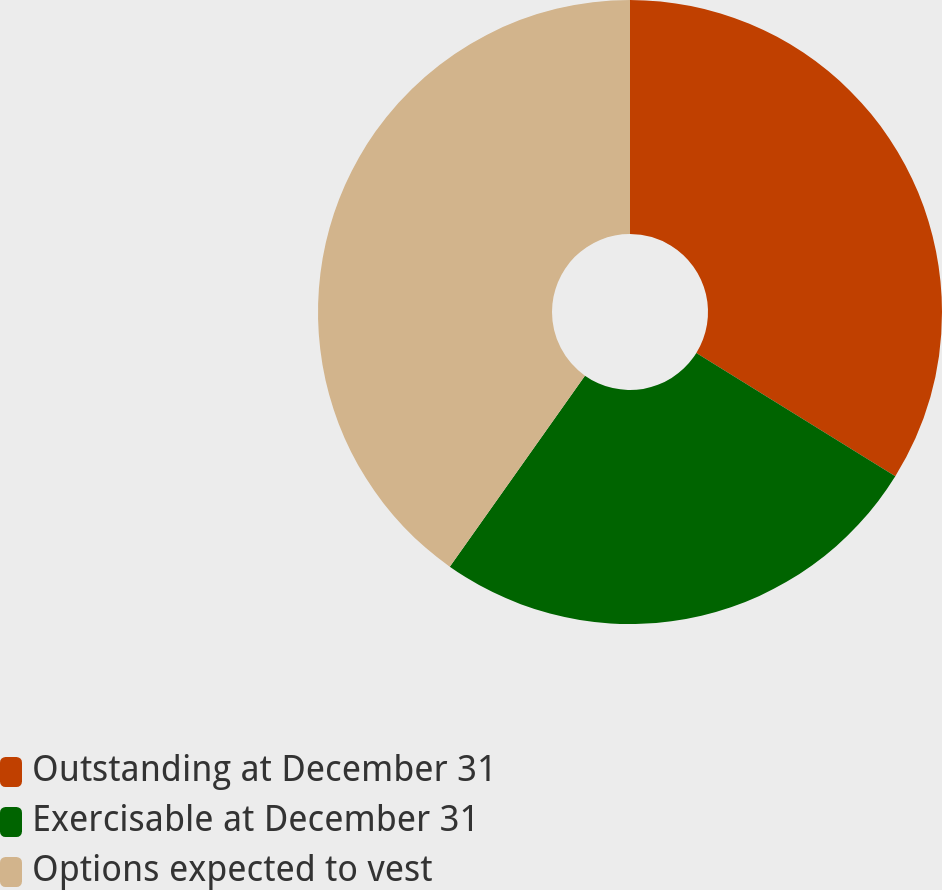Convert chart to OTSL. <chart><loc_0><loc_0><loc_500><loc_500><pie_chart><fcel>Outstanding at December 31<fcel>Exercisable at December 31<fcel>Options expected to vest<nl><fcel>33.82%<fcel>25.98%<fcel>40.2%<nl></chart> 